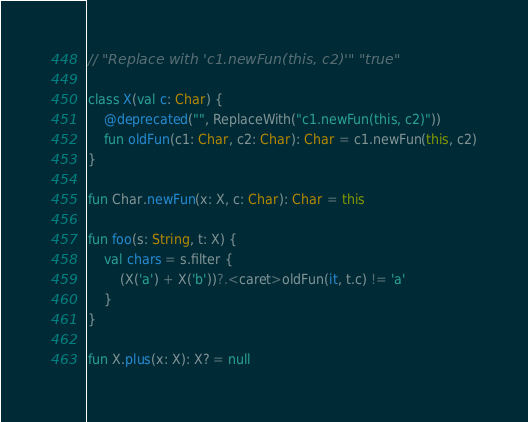Convert code to text. <code><loc_0><loc_0><loc_500><loc_500><_Kotlin_>// "Replace with 'c1.newFun(this, c2)'" "true"

class X(val c: Char) {
    @deprecated("", ReplaceWith("c1.newFun(this, c2)"))
    fun oldFun(c1: Char, c2: Char): Char = c1.newFun(this, c2)
}

fun Char.newFun(x: X, c: Char): Char = this

fun foo(s: String, t: X) {
    val chars = s.filter {
        (X('a') + X('b'))?.<caret>oldFun(it, t.c) != 'a'
    }
}

fun X.plus(x: X): X? = null</code> 